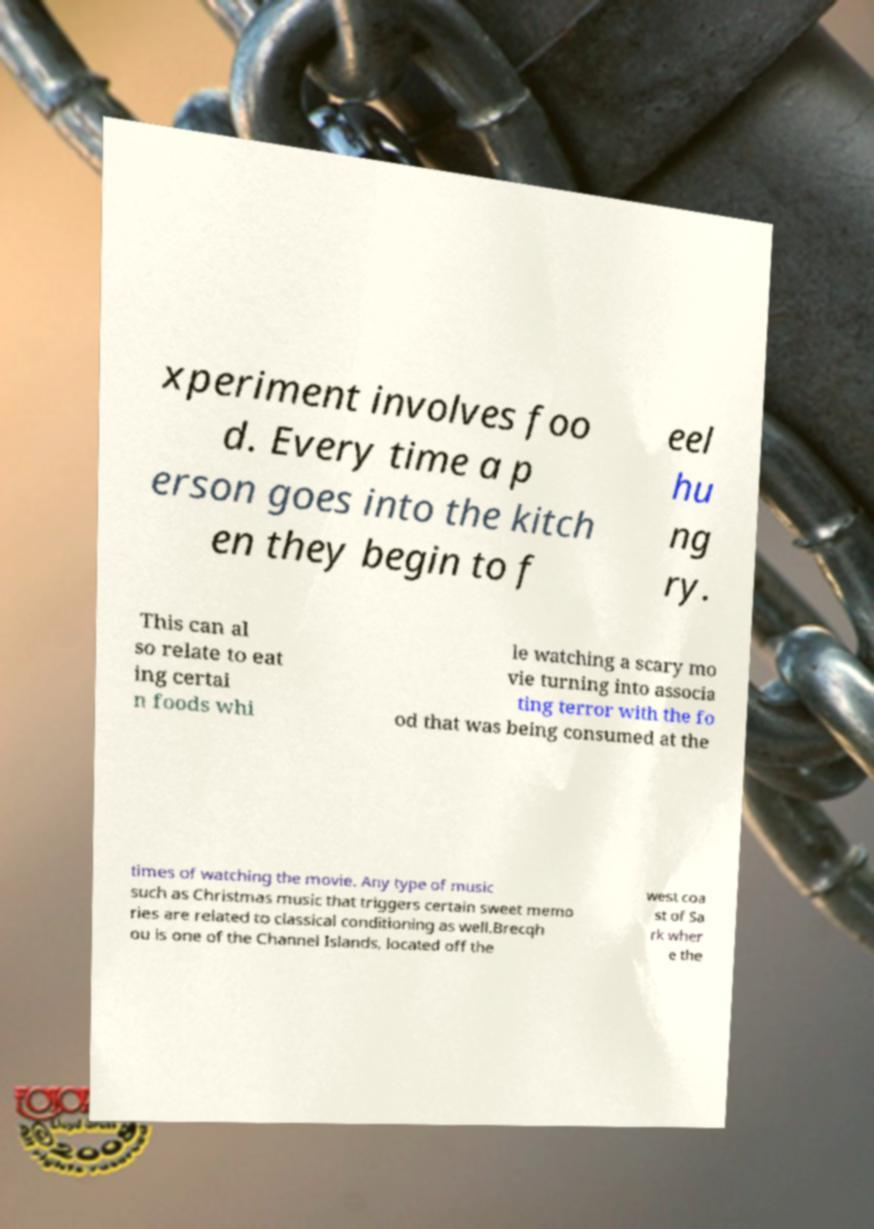What messages or text are displayed in this image? I need them in a readable, typed format. xperiment involves foo d. Every time a p erson goes into the kitch en they begin to f eel hu ng ry. This can al so relate to eat ing certai n foods whi le watching a scary mo vie turning into associa ting terror with the fo od that was being consumed at the times of watching the movie. Any type of music such as Christmas music that triggers certain sweet memo ries are related to classical conditioning as well.Brecqh ou is one of the Channel Islands, located off the west coa st of Sa rk wher e the 